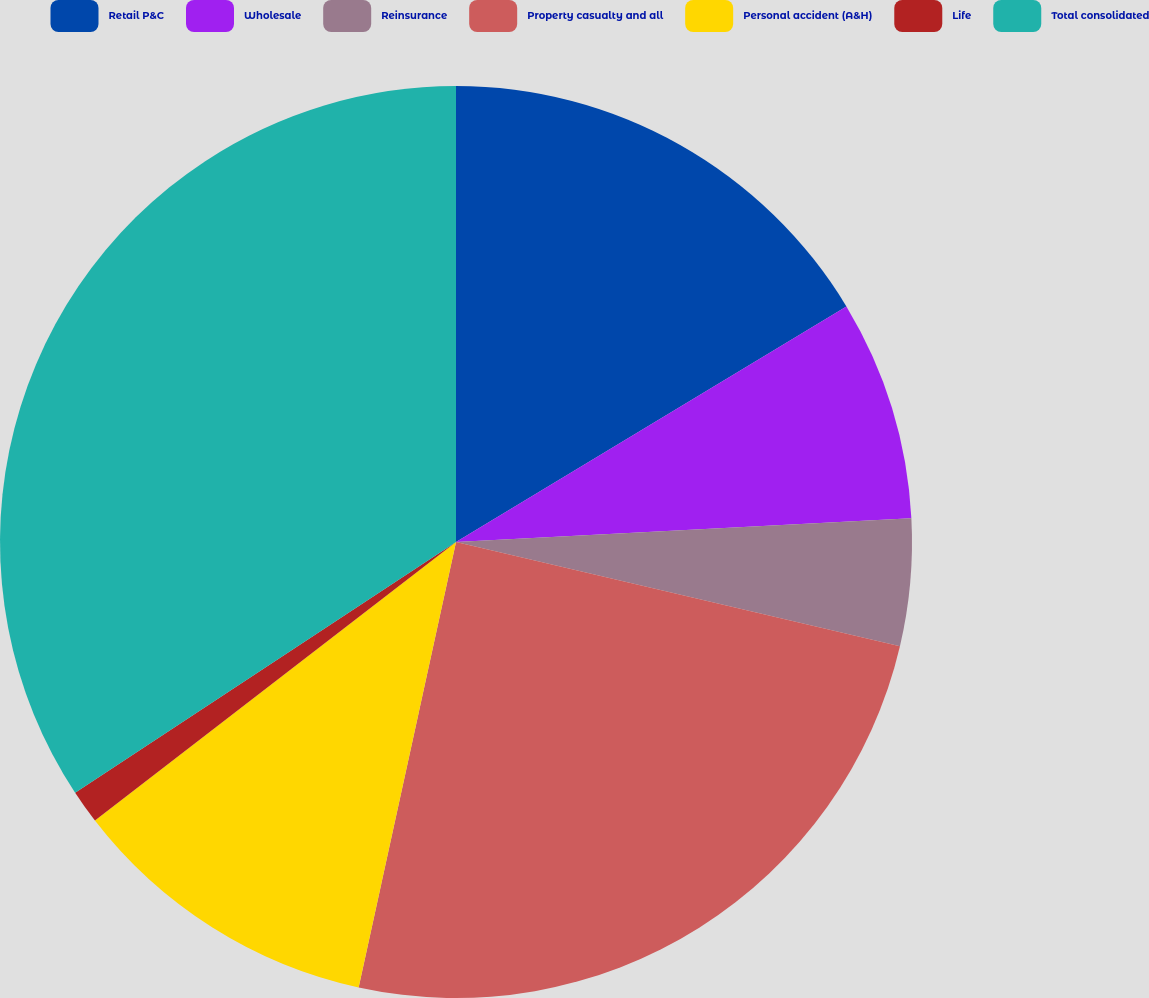Convert chart. <chart><loc_0><loc_0><loc_500><loc_500><pie_chart><fcel>Retail P&C<fcel>Wholesale<fcel>Reinsurance<fcel>Property casualty and all<fcel>Personal accident (A&H)<fcel>Life<fcel>Total consolidated<nl><fcel>16.36%<fcel>7.81%<fcel>4.5%<fcel>24.76%<fcel>11.12%<fcel>1.19%<fcel>34.27%<nl></chart> 